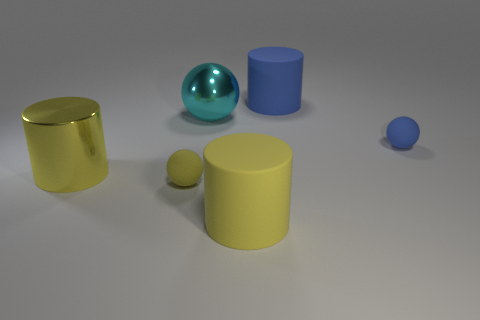Add 3 small purple matte objects. How many objects exist? 9 Subtract all brown shiny blocks. Subtract all cyan balls. How many objects are left? 5 Add 1 tiny spheres. How many tiny spheres are left? 3 Add 4 tiny purple rubber spheres. How many tiny purple rubber spheres exist? 4 Subtract 0 cyan cylinders. How many objects are left? 6 